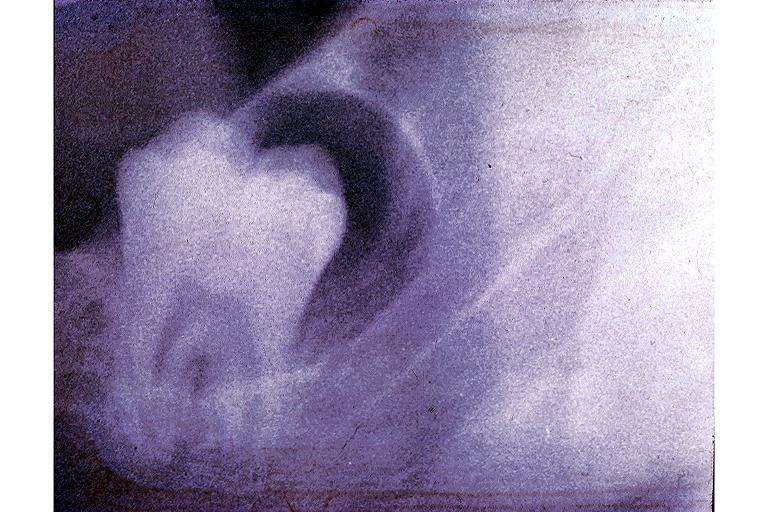does this image show dentigerous cyst?
Answer the question using a single word or phrase. Yes 